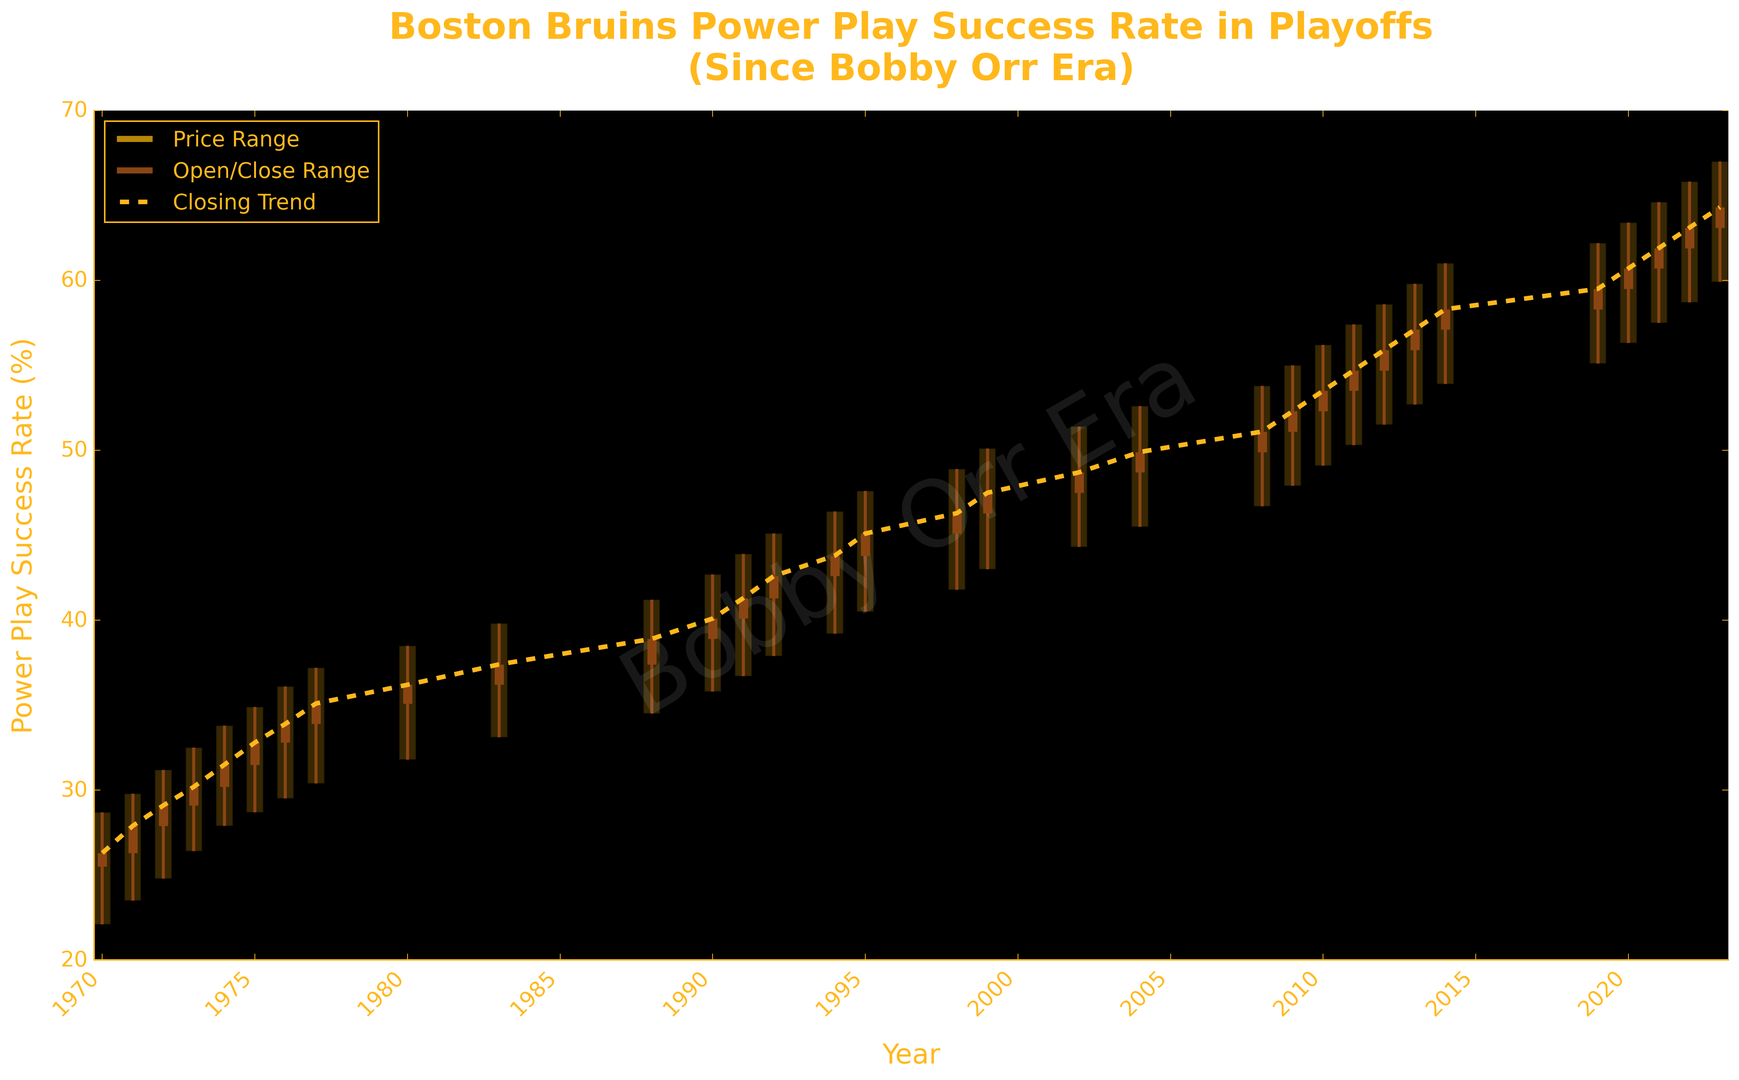When did the Boston Bruins' power play success rate reach its peak, and what was that rate? Based on the highest point visible on the candlestick chart, locate the year and the corresponding highest rate. The highest point on the chart is in 2023 with a rate of 67.0%.
Answer: 2023, 67.0% How did the power play success rate in 1988 compare to 1991? Identify the "Close" values for 1988 and 1991 respectively from the chart, where the "Close" value represents the final power play success rate for that year. In 1988, the "Close" rate is 38.9%, and in 1991, it's 41.3%. Comparing these, 41.3% (1991) is higher than 38.9% (1988).
Answer: 1991 was higher, 41.3% vs 38.9% What trend can be seen in the power play success rate from 2010 to 2014? Trace the "Close" values from the years 2010 (53.5%) to 2014 (58.3%). There is a general upward trend as each year's closing rate increases step-by-step in this period.
Answer: Upward trend Which year had the greatest difference between the highest and lowest power play success rates? To find this, calculate the difference (High - Low) for each year from the chart. The greatest difference appears to be in 2023 with a difference calculated from (67.0 - 59.9 = 7.1).
Answer: 2023, difference of 7.1% What happened to the power play success rate trend after 2010 during consecutive playoff seasons? Observing the candlestick chart "Close" values after 2010: 2011 (54.7%), 2012 (55.9%), 2013 (57.1%), 2014 (58.3%). The trend suggests a steady increase in the success rate.
Answer: Increased steadily What is the average power play success rate for the playoff years shown from 1980 to 1990? Extract the "Close" values from the chart: 1980 (36.2), 1983 (37.4), 1988 (38.9), 1990 (40.1). Sum these values (36.2 + 37.4 + 38.9 + 40.1 = 152.6), and divide by the total number of years (4), resulting in an average of 38.15%.
Answer: 38.15% In what year did the power play success rate first exceed 50%? From the chart, identify the first year where the "Close" rate is greater than 50%. The first occurrence is in 2008 with a closing rate of 51.1%.
Answer: 2008 